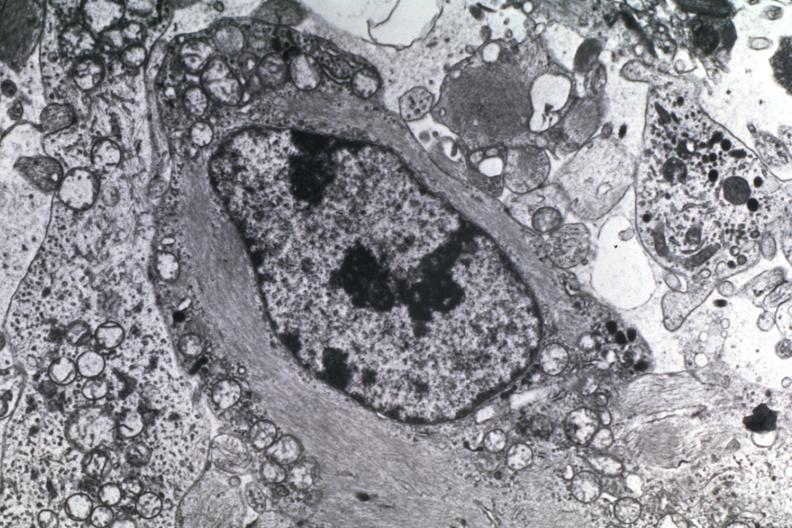what is present?
Answer the question using a single word or phrase. Astrocytoma 